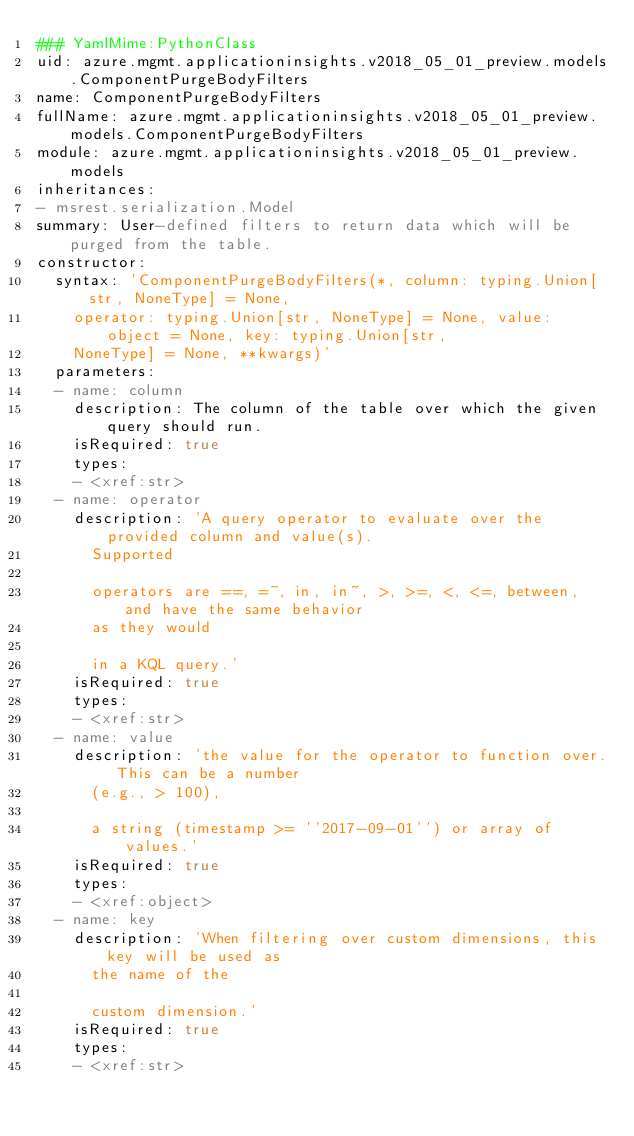<code> <loc_0><loc_0><loc_500><loc_500><_YAML_>### YamlMime:PythonClass
uid: azure.mgmt.applicationinsights.v2018_05_01_preview.models.ComponentPurgeBodyFilters
name: ComponentPurgeBodyFilters
fullName: azure.mgmt.applicationinsights.v2018_05_01_preview.models.ComponentPurgeBodyFilters
module: azure.mgmt.applicationinsights.v2018_05_01_preview.models
inheritances:
- msrest.serialization.Model
summary: User-defined filters to return data which will be purged from the table.
constructor:
  syntax: 'ComponentPurgeBodyFilters(*, column: typing.Union[str, NoneType] = None,
    operator: typing.Union[str, NoneType] = None, value: object = None, key: typing.Union[str,
    NoneType] = None, **kwargs)'
  parameters:
  - name: column
    description: The column of the table over which the given query should run.
    isRequired: true
    types:
    - <xref:str>
  - name: operator
    description: 'A query operator to evaluate over the provided column and value(s).
      Supported

      operators are ==, =~, in, in~, >, >=, <, <=, between, and have the same behavior
      as they would

      in a KQL query.'
    isRequired: true
    types:
    - <xref:str>
  - name: value
    description: 'the value for the operator to function over. This can be a number
      (e.g., > 100),

      a string (timestamp >= ''2017-09-01'') or array of values.'
    isRequired: true
    types:
    - <xref:object>
  - name: key
    description: 'When filtering over custom dimensions, this key will be used as
      the name of the

      custom dimension.'
    isRequired: true
    types:
    - <xref:str>
</code> 